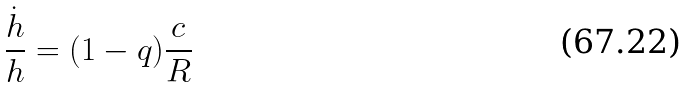<formula> <loc_0><loc_0><loc_500><loc_500>\frac { \dot { h } } { h } = ( 1 - q ) \frac { c } { R }</formula> 